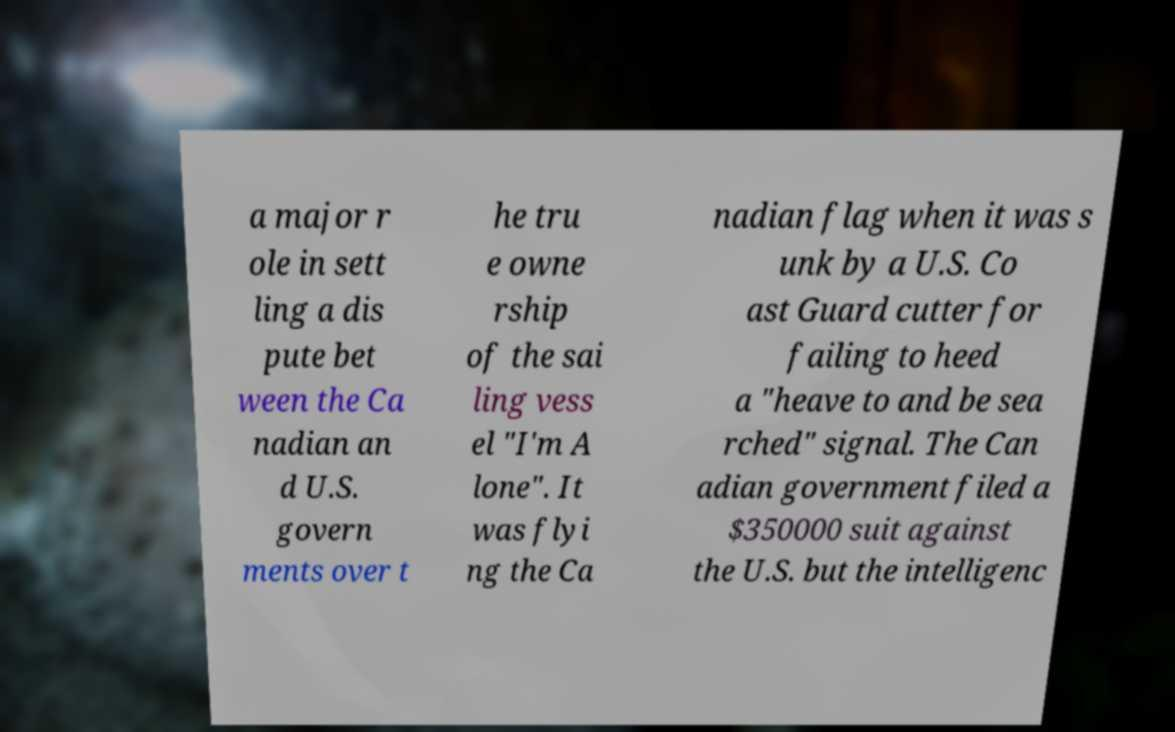Could you extract and type out the text from this image? a major r ole in sett ling a dis pute bet ween the Ca nadian an d U.S. govern ments over t he tru e owne rship of the sai ling vess el "I'm A lone". It was flyi ng the Ca nadian flag when it was s unk by a U.S. Co ast Guard cutter for failing to heed a "heave to and be sea rched" signal. The Can adian government filed a $350000 suit against the U.S. but the intelligenc 